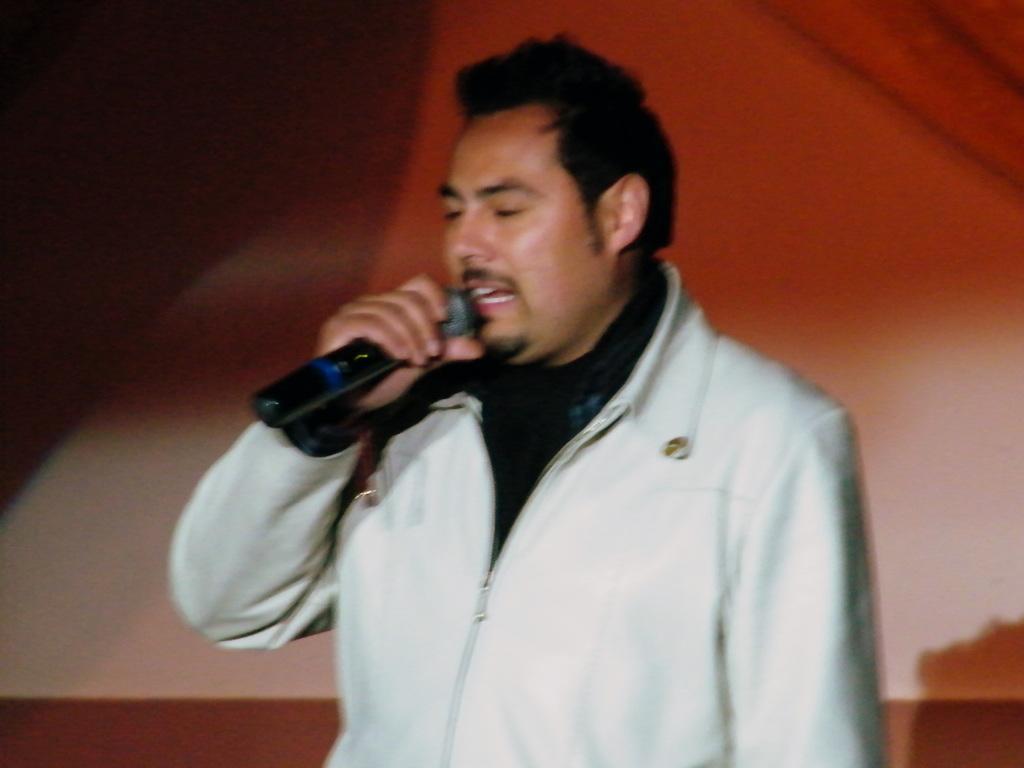Please provide a concise description of this image. This image consists of a person. He is holding mic in his hand. He is wearing white color jacket and black color t-shirt. He singing something. 